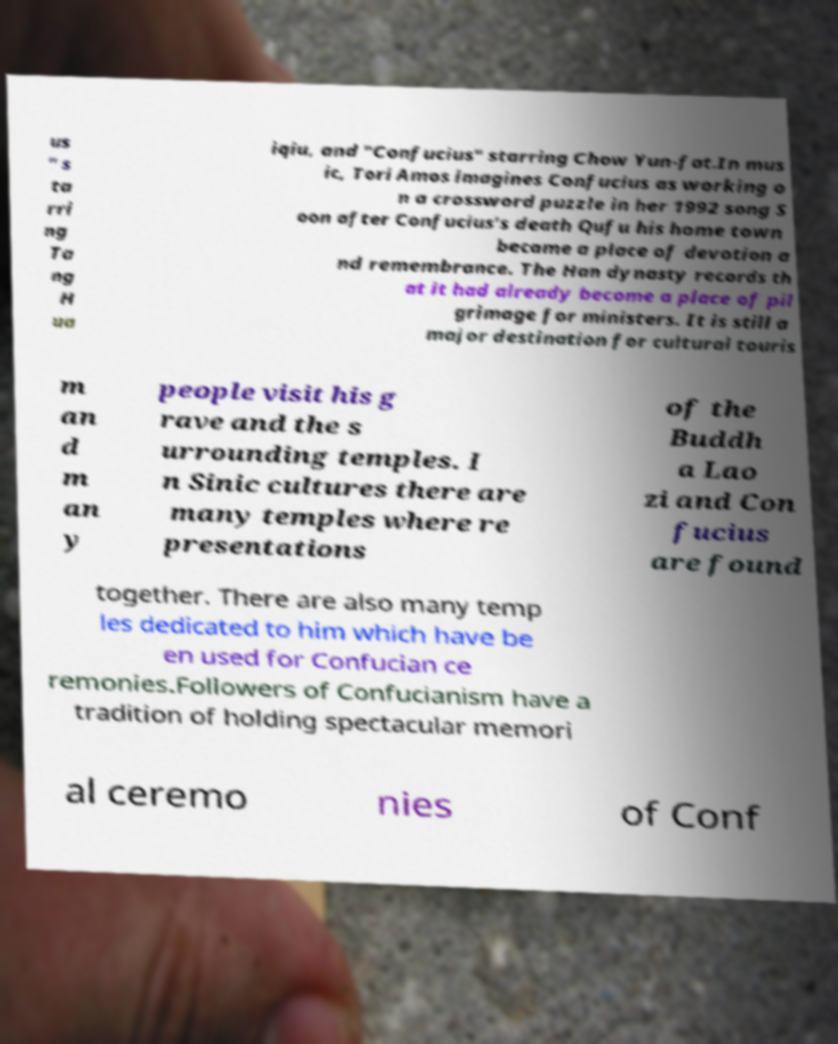Can you accurately transcribe the text from the provided image for me? us " s ta rri ng Ta ng H ua iqiu, and "Confucius" starring Chow Yun-fat.In mus ic, Tori Amos imagines Confucius as working o n a crossword puzzle in her 1992 song S oon after Confucius's death Qufu his home town became a place of devotion a nd remembrance. The Han dynasty records th at it had already become a place of pil grimage for ministers. It is still a major destination for cultural touris m an d m an y people visit his g rave and the s urrounding temples. I n Sinic cultures there are many temples where re presentations of the Buddh a Lao zi and Con fucius are found together. There are also many temp les dedicated to him which have be en used for Confucian ce remonies.Followers of Confucianism have a tradition of holding spectacular memori al ceremo nies of Conf 